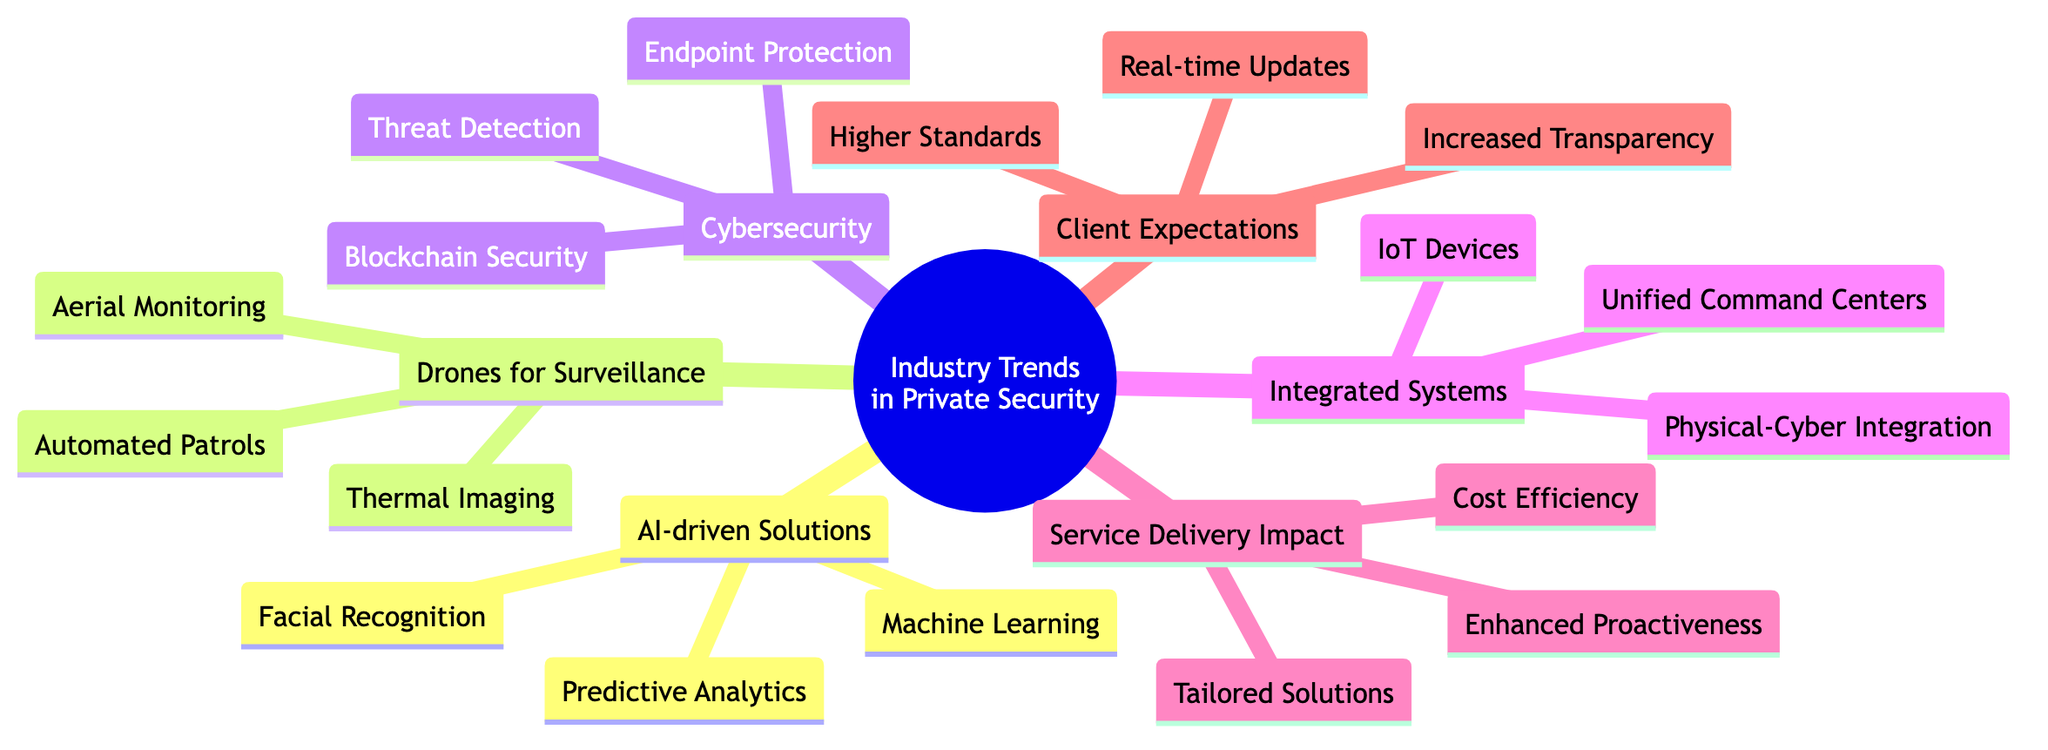What are the three subcategories of AI-driven Security Solutions? The diagram categorizes AI-driven Security Solutions into three subcategories: Facial Recognition, Predictive Analytics, and Machine Learning Algorithms.
Answer: Facial Recognition, Predictive Analytics, Machine Learning Algorithms How many impacts on Service Delivery are listed in the diagram? The diagram lists three impacts on Service Delivery: Enhanced Proactiveness, Cost Efficiency, and Tailored Solutions. By counting these nodes, we find the total is three.
Answer: 3 What enhances visibility in low-light conditions according to the diagram? The diagram specifies that Thermal Imaging is responsible for enhancing visibility in low-light or obscured conditions, as directly stated under the Drones for Surveillance category.
Answer: Thermal Imaging What type of integration is described within Integrated Security Systems? The diagram indicates that Integrated Security Systems include Physical and Cyber Integration, which combines physical security with cybersecurity protocols.
Answer: Physical and Cyber Integration What is the expectation regarding security updates from clients? According to the diagram, clients demand Real-time Updates, meaning they expect instant access to security status and incident reports.
Answer: Real-time Updates Which technology is mentioned for enhancing cybersecurity? The diagram lists several technologies for enhancing cybersecurity, including Endpoint Protection, Advanced Threat Detection, and Blockchain for Security. The question implies asking for any one of these; thus, we can say Endpoint Protection.
Answer: Endpoint Protection How does Predictive Analytics contribute to security? The diagram states that Predictive Analytics anticipates security breaches and patterns of behavior, indicating its role in predicting potential security issues before they happen.
Answer: Anticipates security breaches and patterns of behavior What integration does the diagram suggest for comprehensive security coverage? The integration of IoT Devices is mentioned as a key component that integrates smart sensors and connected technology aimed at comprehensive security coverage, as shown in the Integrated Security Systems section.
Answer: IoT Devices 